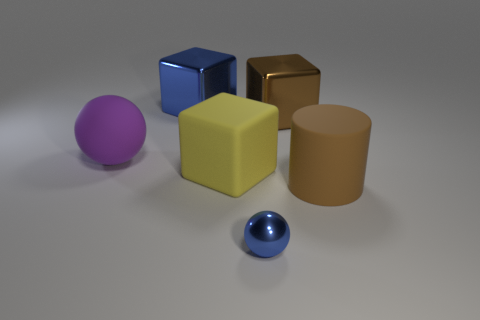Subtract all big metal blocks. How many blocks are left? 1 Subtract all yellow cubes. How many cubes are left? 2 Add 3 big blue metallic blocks. How many objects exist? 9 Subtract all green blocks. Subtract all blue spheres. How many blocks are left? 3 Add 3 big rubber cylinders. How many big rubber cylinders are left? 4 Add 3 blocks. How many blocks exist? 6 Subtract 0 red cubes. How many objects are left? 6 Subtract all spheres. How many objects are left? 4 Subtract all small gray rubber cylinders. Subtract all big yellow matte objects. How many objects are left? 5 